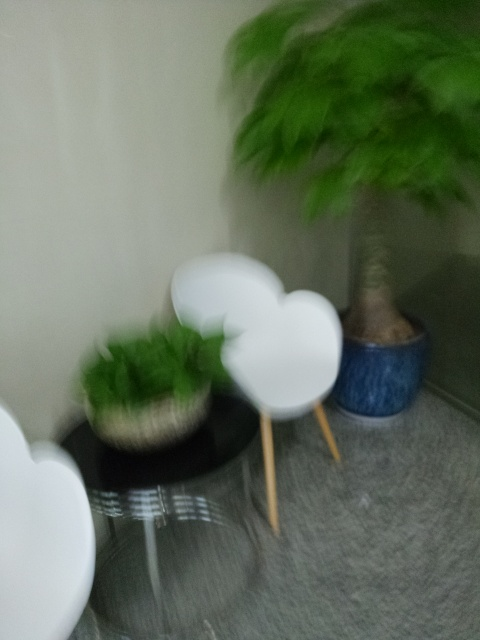How could the quality of this photo be improved? To improve the quality of the photo, it should be taken with a steady hand or a tripod to avoid motion blur. Ensuring proper focus and lighting would also enhance the clarity and bring out the details in the furniture and plants. 